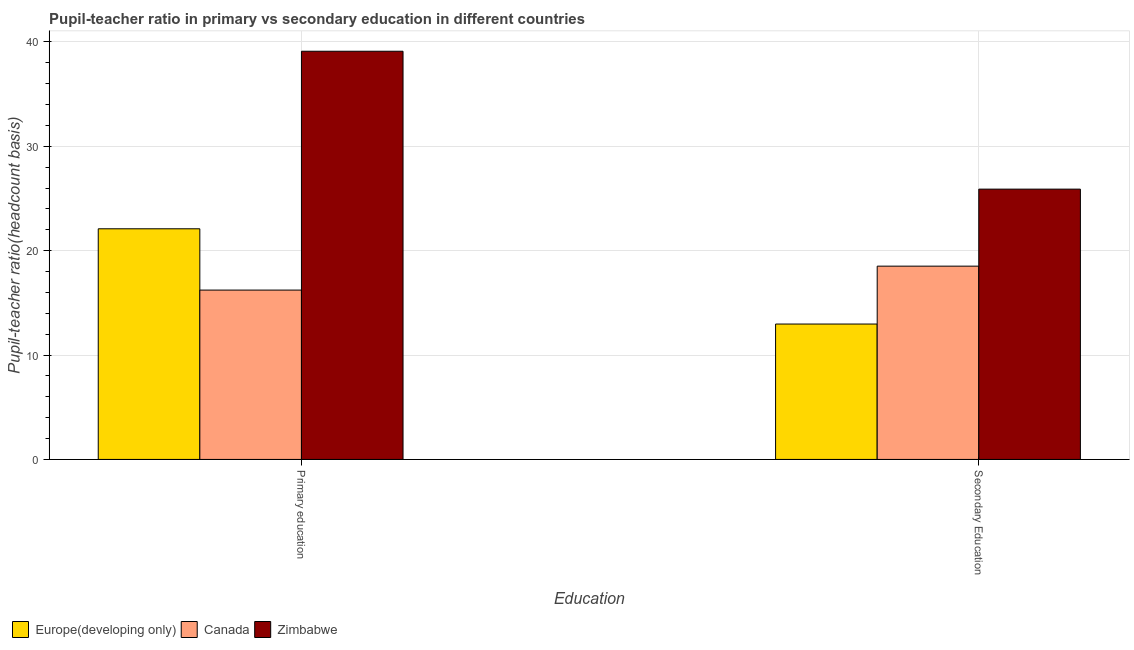How many groups of bars are there?
Your answer should be very brief. 2. What is the label of the 1st group of bars from the left?
Your answer should be very brief. Primary education. What is the pupil teacher ratio on secondary education in Canada?
Ensure brevity in your answer.  18.52. Across all countries, what is the maximum pupil-teacher ratio in primary education?
Offer a very short reply. 39.11. Across all countries, what is the minimum pupil teacher ratio on secondary education?
Offer a terse response. 12.97. In which country was the pupil teacher ratio on secondary education maximum?
Keep it short and to the point. Zimbabwe. What is the total pupil teacher ratio on secondary education in the graph?
Your answer should be very brief. 57.39. What is the difference between the pupil teacher ratio on secondary education in Canada and that in Europe(developing only)?
Your answer should be compact. 5.55. What is the difference between the pupil teacher ratio on secondary education in Europe(developing only) and the pupil-teacher ratio in primary education in Zimbabwe?
Your response must be concise. -26.14. What is the average pupil-teacher ratio in primary education per country?
Offer a very short reply. 25.81. What is the difference between the pupil teacher ratio on secondary education and pupil-teacher ratio in primary education in Europe(developing only)?
Provide a succinct answer. -9.13. What is the ratio of the pupil teacher ratio on secondary education in Canada to that in Europe(developing only)?
Your answer should be compact. 1.43. In how many countries, is the pupil teacher ratio on secondary education greater than the average pupil teacher ratio on secondary education taken over all countries?
Offer a terse response. 1. How many bars are there?
Your answer should be very brief. 6. Are all the bars in the graph horizontal?
Keep it short and to the point. No. Does the graph contain grids?
Ensure brevity in your answer.  Yes. What is the title of the graph?
Give a very brief answer. Pupil-teacher ratio in primary vs secondary education in different countries. What is the label or title of the X-axis?
Provide a succinct answer. Education. What is the label or title of the Y-axis?
Give a very brief answer. Pupil-teacher ratio(headcount basis). What is the Pupil-teacher ratio(headcount basis) in Europe(developing only) in Primary education?
Your answer should be very brief. 22.1. What is the Pupil-teacher ratio(headcount basis) of Canada in Primary education?
Make the answer very short. 16.23. What is the Pupil-teacher ratio(headcount basis) of Zimbabwe in Primary education?
Provide a succinct answer. 39.11. What is the Pupil-teacher ratio(headcount basis) of Europe(developing only) in Secondary Education?
Your answer should be very brief. 12.97. What is the Pupil-teacher ratio(headcount basis) in Canada in Secondary Education?
Ensure brevity in your answer.  18.52. What is the Pupil-teacher ratio(headcount basis) of Zimbabwe in Secondary Education?
Your answer should be very brief. 25.9. Across all Education, what is the maximum Pupil-teacher ratio(headcount basis) of Europe(developing only)?
Provide a succinct answer. 22.1. Across all Education, what is the maximum Pupil-teacher ratio(headcount basis) in Canada?
Make the answer very short. 18.52. Across all Education, what is the maximum Pupil-teacher ratio(headcount basis) in Zimbabwe?
Give a very brief answer. 39.11. Across all Education, what is the minimum Pupil-teacher ratio(headcount basis) in Europe(developing only)?
Keep it short and to the point. 12.97. Across all Education, what is the minimum Pupil-teacher ratio(headcount basis) in Canada?
Provide a short and direct response. 16.23. Across all Education, what is the minimum Pupil-teacher ratio(headcount basis) of Zimbabwe?
Provide a short and direct response. 25.9. What is the total Pupil-teacher ratio(headcount basis) in Europe(developing only) in the graph?
Make the answer very short. 35.07. What is the total Pupil-teacher ratio(headcount basis) in Canada in the graph?
Keep it short and to the point. 34.74. What is the total Pupil-teacher ratio(headcount basis) of Zimbabwe in the graph?
Offer a terse response. 65.01. What is the difference between the Pupil-teacher ratio(headcount basis) of Europe(developing only) in Primary education and that in Secondary Education?
Ensure brevity in your answer.  9.13. What is the difference between the Pupil-teacher ratio(headcount basis) in Canada in Primary education and that in Secondary Education?
Provide a short and direct response. -2.29. What is the difference between the Pupil-teacher ratio(headcount basis) of Zimbabwe in Primary education and that in Secondary Education?
Provide a short and direct response. 13.21. What is the difference between the Pupil-teacher ratio(headcount basis) in Europe(developing only) in Primary education and the Pupil-teacher ratio(headcount basis) in Canada in Secondary Education?
Offer a terse response. 3.58. What is the difference between the Pupil-teacher ratio(headcount basis) in Europe(developing only) in Primary education and the Pupil-teacher ratio(headcount basis) in Zimbabwe in Secondary Education?
Give a very brief answer. -3.8. What is the difference between the Pupil-teacher ratio(headcount basis) in Canada in Primary education and the Pupil-teacher ratio(headcount basis) in Zimbabwe in Secondary Education?
Your answer should be compact. -9.67. What is the average Pupil-teacher ratio(headcount basis) of Europe(developing only) per Education?
Your response must be concise. 17.53. What is the average Pupil-teacher ratio(headcount basis) in Canada per Education?
Your answer should be very brief. 17.37. What is the average Pupil-teacher ratio(headcount basis) of Zimbabwe per Education?
Make the answer very short. 32.5. What is the difference between the Pupil-teacher ratio(headcount basis) in Europe(developing only) and Pupil-teacher ratio(headcount basis) in Canada in Primary education?
Make the answer very short. 5.87. What is the difference between the Pupil-teacher ratio(headcount basis) of Europe(developing only) and Pupil-teacher ratio(headcount basis) of Zimbabwe in Primary education?
Keep it short and to the point. -17.01. What is the difference between the Pupil-teacher ratio(headcount basis) in Canada and Pupil-teacher ratio(headcount basis) in Zimbabwe in Primary education?
Provide a succinct answer. -22.88. What is the difference between the Pupil-teacher ratio(headcount basis) in Europe(developing only) and Pupil-teacher ratio(headcount basis) in Canada in Secondary Education?
Keep it short and to the point. -5.55. What is the difference between the Pupil-teacher ratio(headcount basis) in Europe(developing only) and Pupil-teacher ratio(headcount basis) in Zimbabwe in Secondary Education?
Provide a succinct answer. -12.93. What is the difference between the Pupil-teacher ratio(headcount basis) of Canada and Pupil-teacher ratio(headcount basis) of Zimbabwe in Secondary Education?
Your response must be concise. -7.38. What is the ratio of the Pupil-teacher ratio(headcount basis) of Europe(developing only) in Primary education to that in Secondary Education?
Provide a succinct answer. 1.7. What is the ratio of the Pupil-teacher ratio(headcount basis) in Canada in Primary education to that in Secondary Education?
Ensure brevity in your answer.  0.88. What is the ratio of the Pupil-teacher ratio(headcount basis) in Zimbabwe in Primary education to that in Secondary Education?
Your response must be concise. 1.51. What is the difference between the highest and the second highest Pupil-teacher ratio(headcount basis) of Europe(developing only)?
Keep it short and to the point. 9.13. What is the difference between the highest and the second highest Pupil-teacher ratio(headcount basis) of Canada?
Your answer should be compact. 2.29. What is the difference between the highest and the second highest Pupil-teacher ratio(headcount basis) in Zimbabwe?
Make the answer very short. 13.21. What is the difference between the highest and the lowest Pupil-teacher ratio(headcount basis) in Europe(developing only)?
Provide a succinct answer. 9.13. What is the difference between the highest and the lowest Pupil-teacher ratio(headcount basis) of Canada?
Your answer should be very brief. 2.29. What is the difference between the highest and the lowest Pupil-teacher ratio(headcount basis) of Zimbabwe?
Offer a terse response. 13.21. 